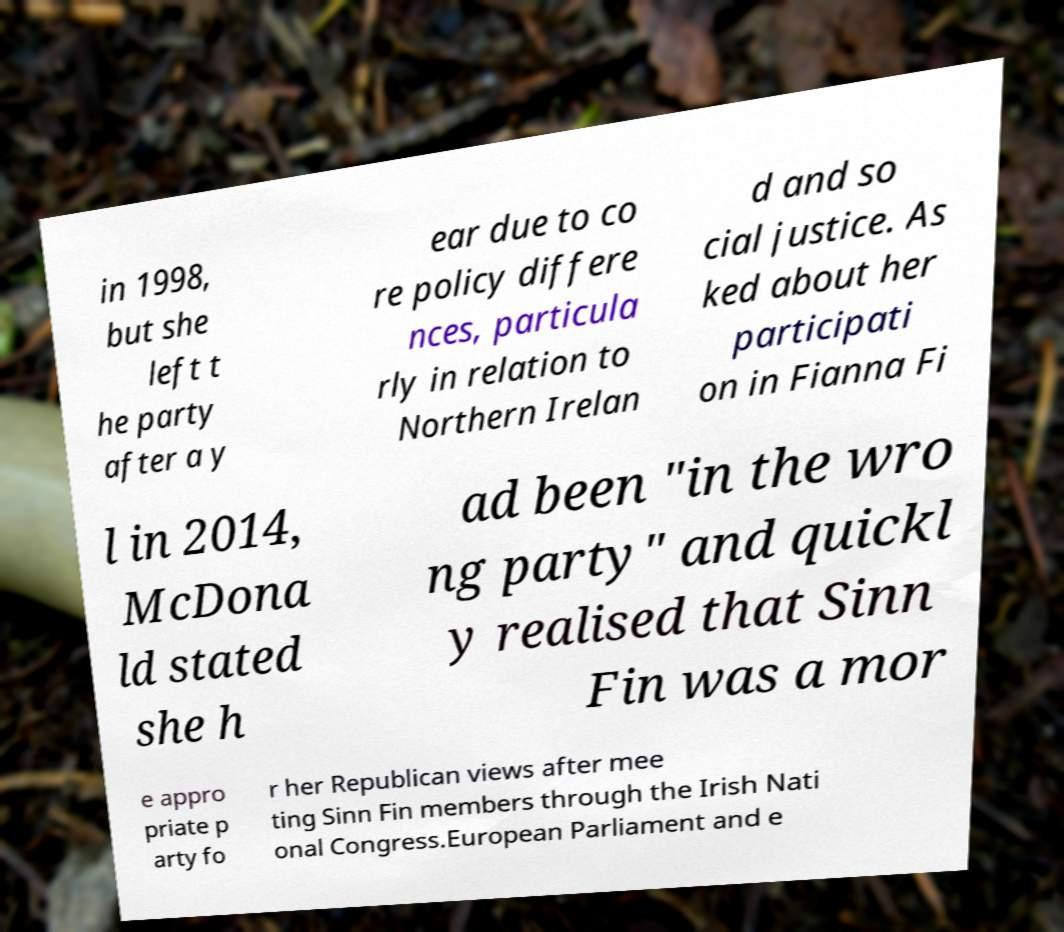I need the written content from this picture converted into text. Can you do that? in 1998, but she left t he party after a y ear due to co re policy differe nces, particula rly in relation to Northern Irelan d and so cial justice. As ked about her participati on in Fianna Fi l in 2014, McDona ld stated she h ad been "in the wro ng party" and quickl y realised that Sinn Fin was a mor e appro priate p arty fo r her Republican views after mee ting Sinn Fin members through the Irish Nati onal Congress.European Parliament and e 